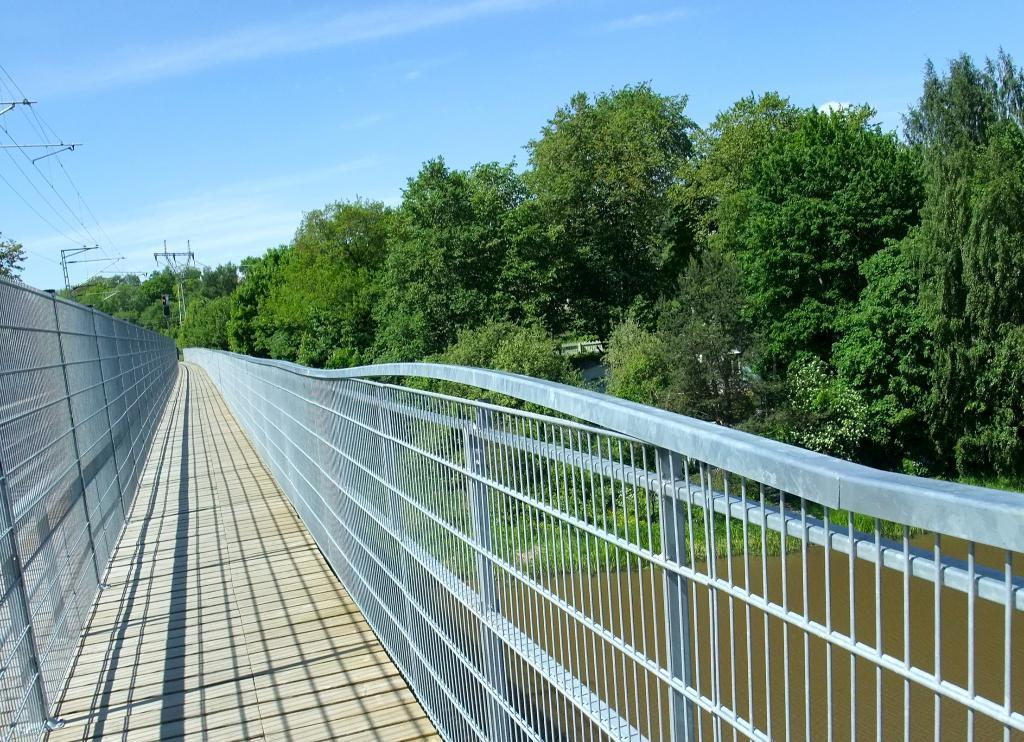What can be seen running through the image? There is a path in the image. What is used to separate or enclose an area in the image? There is a fence in the image. What type of vegetation is visible in the image? There are trees visible from left to right in the image. What is present on the right side of the image? There is water on the right side of the image. What is the color of the sky in the image? The sky is blue in color. Where is the waste disposal area in the image? There is no waste disposal area present in the image. What type of camp can be seen in the image? There is no camp present in the image. 